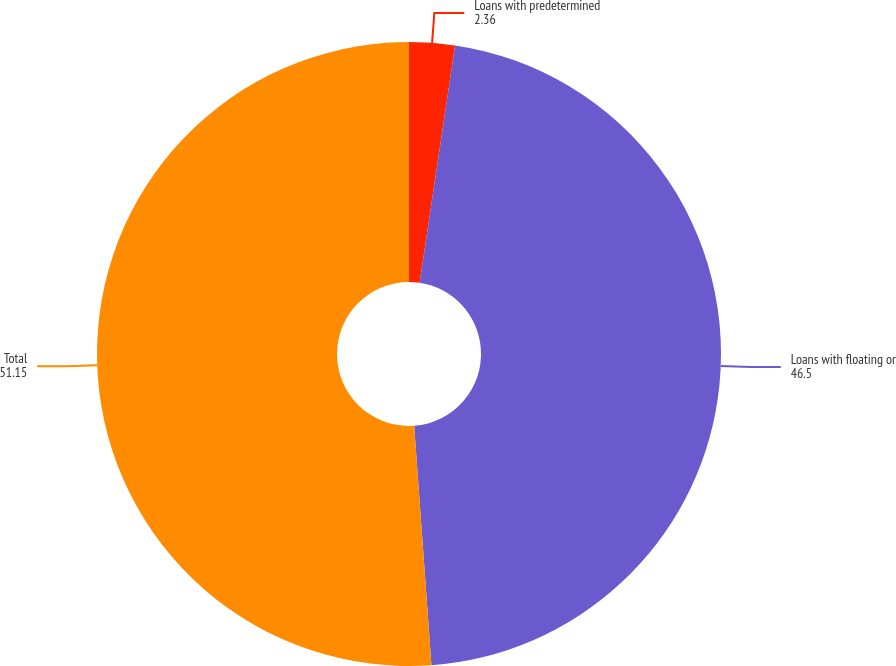Convert chart. <chart><loc_0><loc_0><loc_500><loc_500><pie_chart><fcel>Loans with predetermined<fcel>Loans with floating or<fcel>Total<nl><fcel>2.36%<fcel>46.5%<fcel>51.15%<nl></chart> 